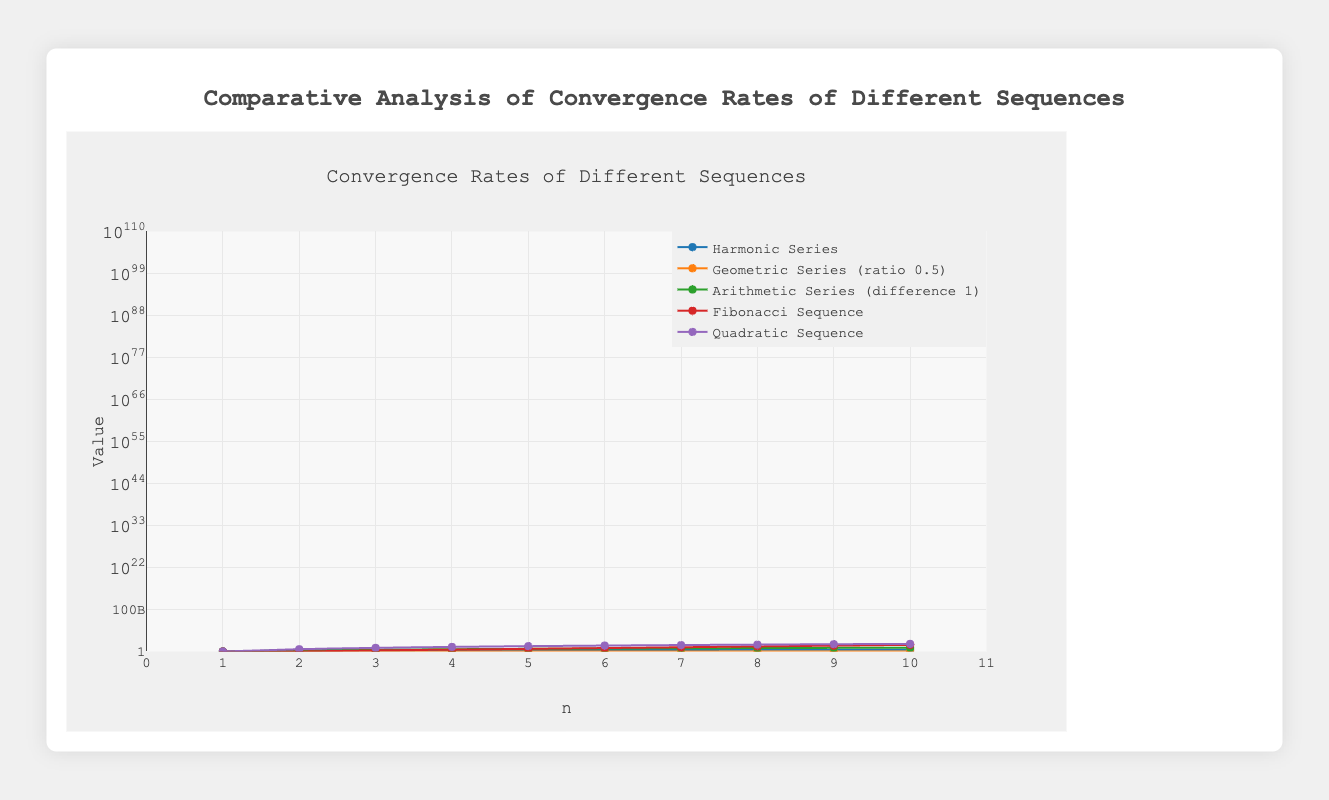Which sequence reaches the highest value by n=10? By looking at the figure, the Fibonacci Sequence reaches the highest value at n=10, with a value of 55.
Answer: Fibonacci Sequence Which two sequences increase the slowest? The Harmonic Series and Geometric Series (ratio 0.5) increase the slowest as their curves appear flatter compared to others.
Answer: Harmonic Series and Geometric Series What is the difference in values between the Arithmetic Series and the Harmonic Series at n=5? At n=5, the Arithmetic Series value is 5 and the Harmonic Series value is 2.283. The difference is 5 - 2.283.
Answer: 2.717 Which sequence shows an exponential growth pattern? The Fibonacci Sequence shows an exponential growth pattern as its curve spikes upward sharply.
Answer: Fibonacci Sequence How does the value of the Quadratic Sequence at n=6 compare to the sum of the Geometric Series (ratio 0.5) at n=5 and the Fibonacci Sequence at n=3? The Quadratic Sequence at n=6 is 36. The Geometric Series (ratio 0.5) at n=5 is 0.96875 and the Fibonacci Sequence at n=3 is 2. 36 is significantly larger than the sum 0.96875 + 2 = 2.96875.
Answer: Larger Which sequence almost reaches 1 the fastest among the plotted sequences? The Geometric Series (ratio 0.5) nearly reaches 1 the fastest, approaching 0.999 at n=10.
Answer: Geometric Series (ratio 0.5) What is the average value of the first 4 terms of the Harmonic Series? Adding the first four terms of the Harmonic Series: 1 + 1.5 + 1.833 + 2.083 gives 6.416. Thus, the average is 6.416/4 = 1.604
Answer: 1.604 Which sequence has more steep increase in its values between n=3 and n=4, Quadratic Sequence or Fibonacci Sequence? The Quadratic Sequence increases from 9 to 16, a difference of 7, while the Fibonacci Sequence increases from 2 to 3, a difference of 1. Hence, the Quadratic Sequence has a steeper increase.
Answer: Quadratic Sequence What is the trend observed in the Harmonic Series beyond n=8? Beyond n=8, the Harmonic Series continues to increase but at a diminishing rate, appearing flat on a log scale.
Answer: Increases at diminishing rate 